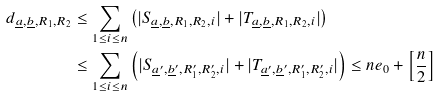Convert formula to latex. <formula><loc_0><loc_0><loc_500><loc_500>d _ { \underline { a } , \underline { b } , R _ { 1 } , R _ { 2 } } & \leq \sum _ { 1 \leq i \leq n } \left ( | S _ { \underline { a } , \underline { b } , R _ { 1 } , R _ { 2 } , i } | + | T _ { \underline { a } , \underline { b } , R _ { 1 } , R _ { 2 } , i } | \right ) \\ & \leq \sum _ { 1 \leq i \leq n } \left ( | S _ { \underline { a } ^ { \prime } , \underline { b } ^ { \prime } , R _ { 1 } ^ { \prime } , R _ { 2 } ^ { \prime } , i } | + | T _ { \underline { a } ^ { \prime } , \underline { b } ^ { \prime } , R _ { 1 } ^ { \prime } , R _ { 2 } ^ { \prime } , i } | \right ) \leq n e _ { 0 } + \left [ \frac { n } { 2 } \right ]</formula> 